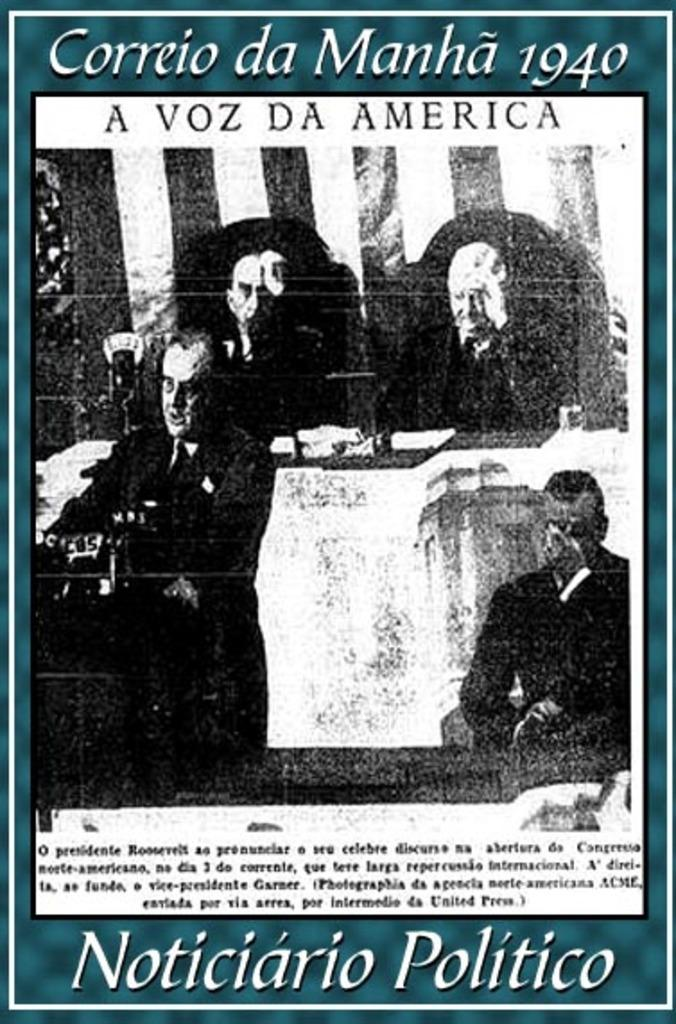What is present in the image that features a design or message? There is a poster in the image. What can be seen on the poster? There are people depicted on the poster. What else is present on the poster besides the images? There is writing on the poster. What type of leaf is being used as a key in the image? There is no leaf or key present in the image; it only features a poster with people and writing on it. 